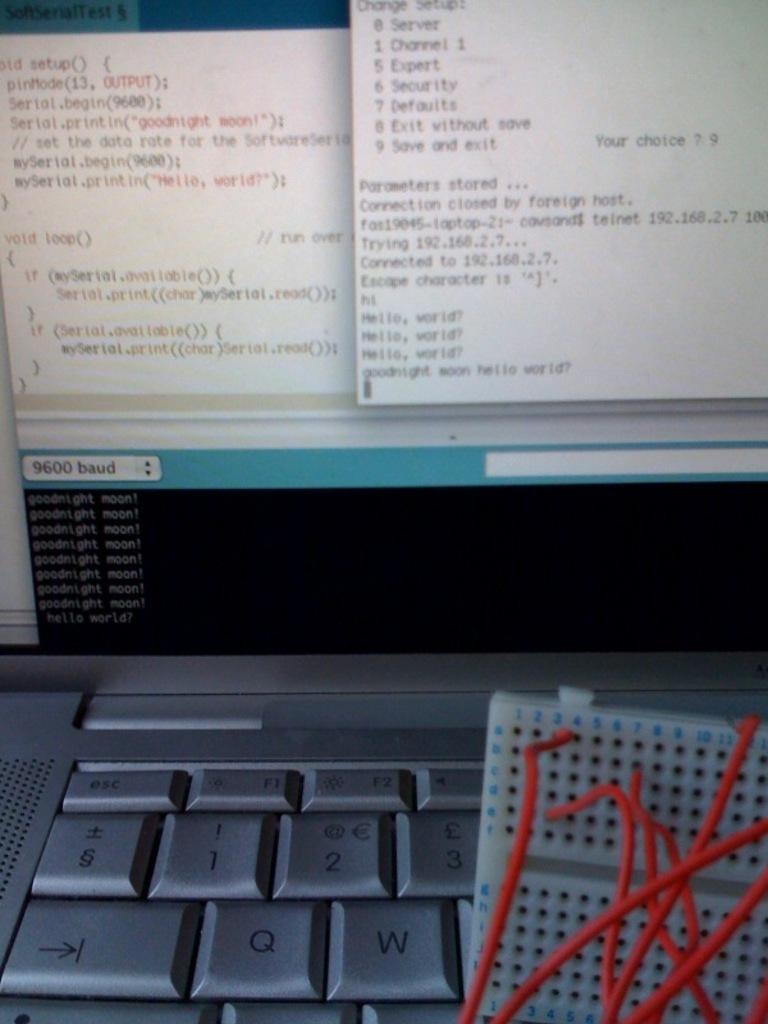What baud speed is indicated in the lower left?
Give a very brief answer. 9600. 